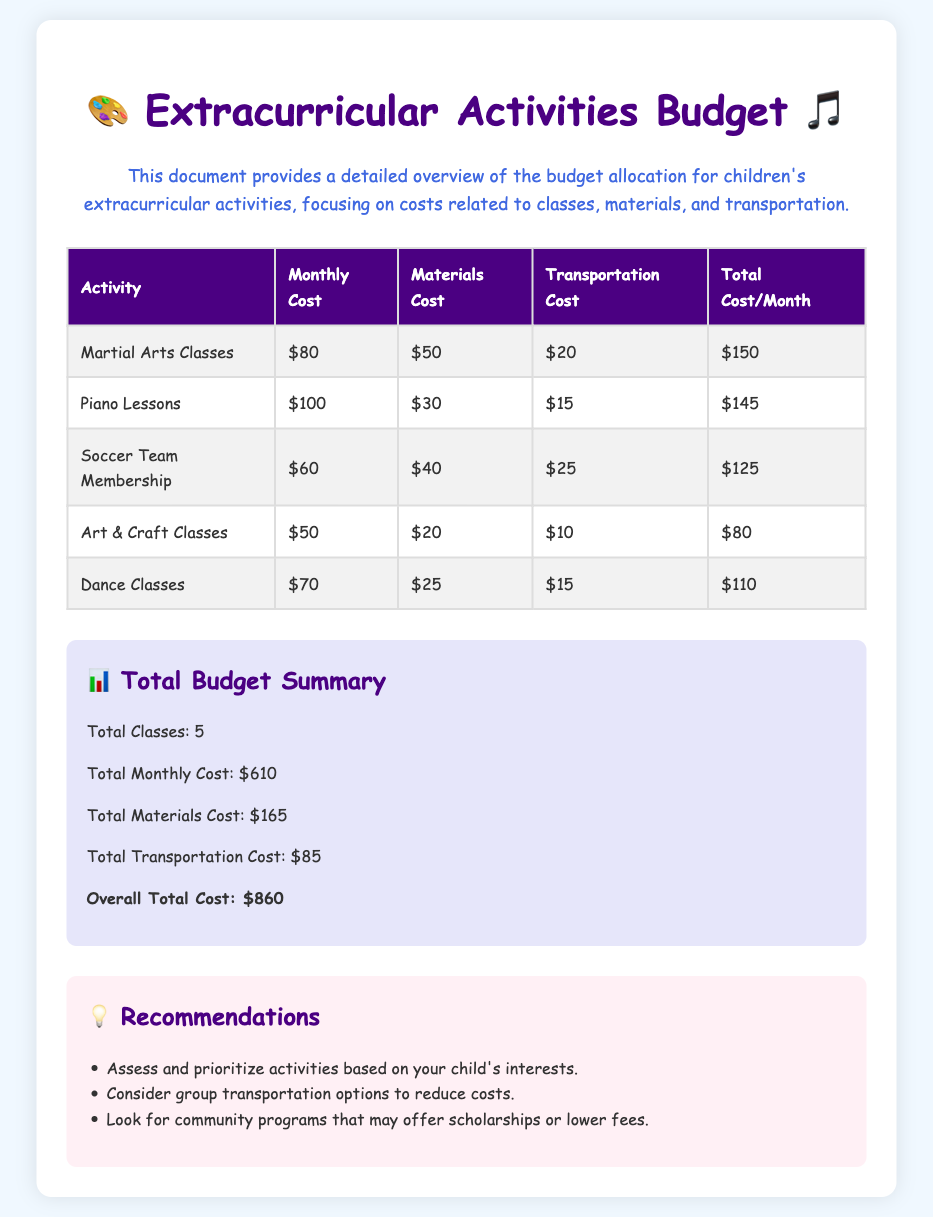What is the monthly cost of Martial Arts Classes? The monthly cost listed for Martial Arts Classes in the document is $80.
Answer: $80 What is the total materials cost for all activities? The total materials cost is the sum of each activity's materials cost, which is $50 + $30 + $40 + $20 + $25 = $165.
Answer: $165 How much does it cost to transport a child to the Soccer Team? The transportation cost for the Soccer Team is $25 as stated in the document.
Answer: $25 What is the total monthly cost for all activities combined? The total monthly cost is the sum of all monthly costs for each activity, which totals $80 + $100 + $60 + $50 + $70 = $610.
Answer: $610 How many activities are listed in the document? The document lists a total of 5 extracurricular activities.
Answer: 5 What is the overall total cost? The overall total cost is indicated in the summary section as $860, which is the total of all expenses.
Answer: $860 What is the transportation cost for Dance Classes? The transportation cost for Dance Classes, as per the document, is $15.
Answer: $15 Which activity has the highest monthly cost? The activity with the highest monthly cost is Piano Lessons, which costs $100.
Answer: Piano Lessons 